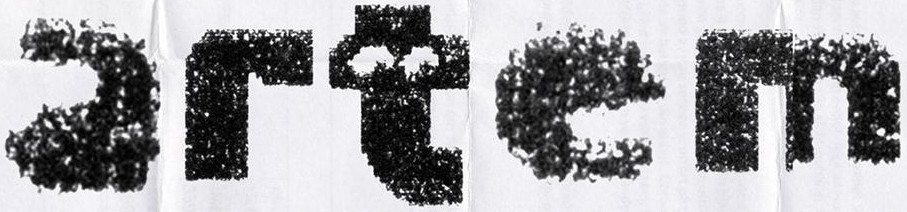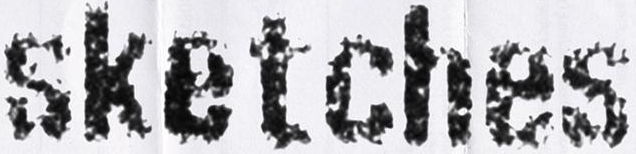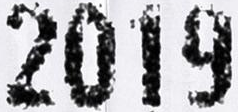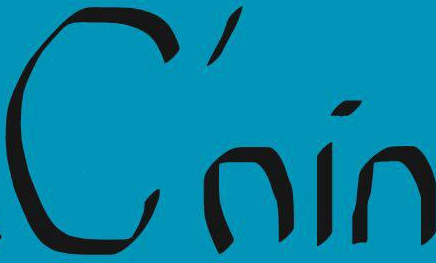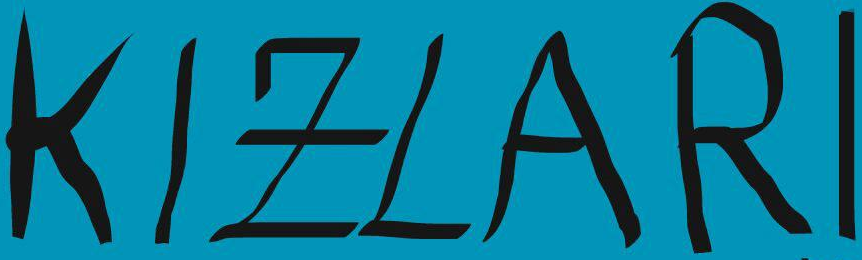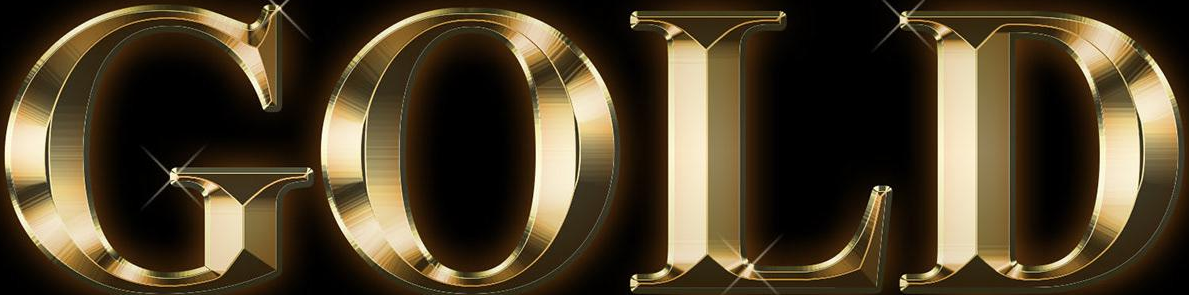Read the text content from these images in order, separated by a semicolon. artem; sketches; 2019; C'nin; KIZLARI; GOLD 